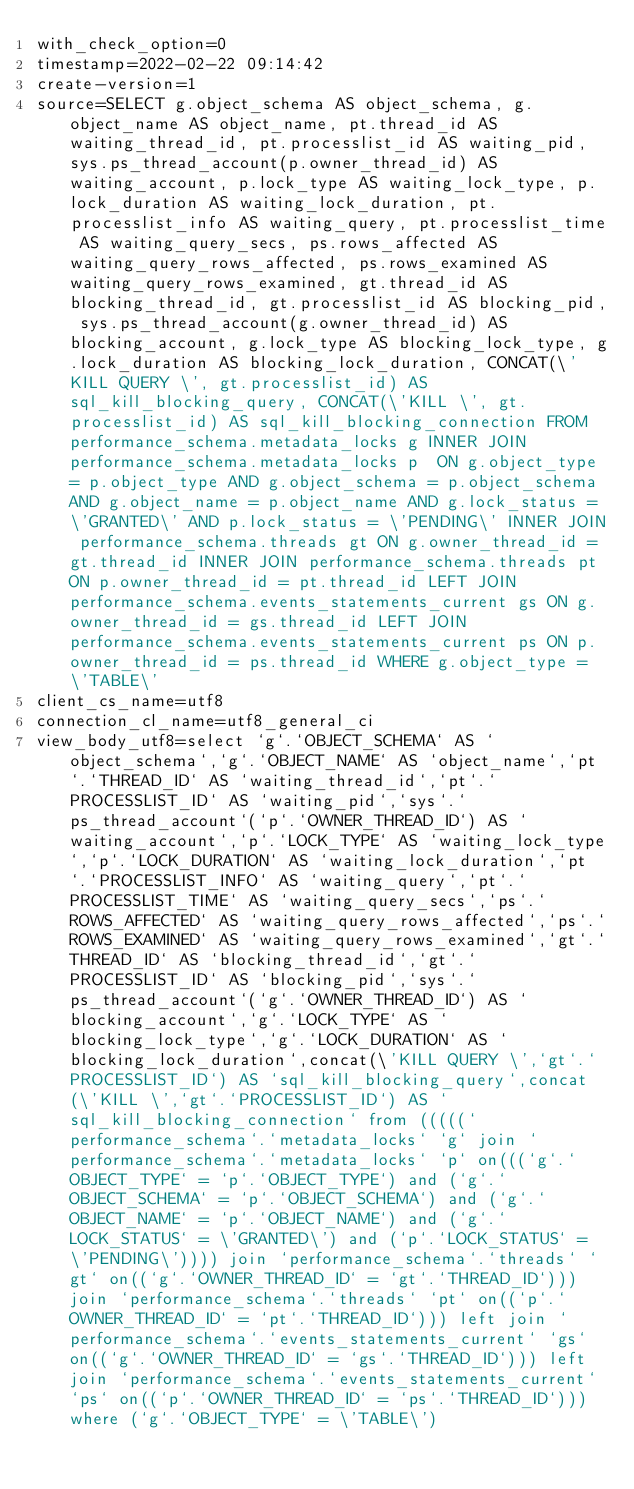Convert code to text. <code><loc_0><loc_0><loc_500><loc_500><_VisualBasic_>with_check_option=0
timestamp=2022-02-22 09:14:42
create-version=1
source=SELECT g.object_schema AS object_schema, g.object_name AS object_name, pt.thread_id AS waiting_thread_id, pt.processlist_id AS waiting_pid, sys.ps_thread_account(p.owner_thread_id) AS waiting_account, p.lock_type AS waiting_lock_type, p.lock_duration AS waiting_lock_duration, pt.processlist_info AS waiting_query, pt.processlist_time AS waiting_query_secs, ps.rows_affected AS waiting_query_rows_affected, ps.rows_examined AS waiting_query_rows_examined, gt.thread_id AS blocking_thread_id, gt.processlist_id AS blocking_pid, sys.ps_thread_account(g.owner_thread_id) AS blocking_account, g.lock_type AS blocking_lock_type, g.lock_duration AS blocking_lock_duration, CONCAT(\'KILL QUERY \', gt.processlist_id) AS sql_kill_blocking_query, CONCAT(\'KILL \', gt.processlist_id) AS sql_kill_blocking_connection FROM performance_schema.metadata_locks g INNER JOIN performance_schema.metadata_locks p  ON g.object_type = p.object_type AND g.object_schema = p.object_schema AND g.object_name = p.object_name AND g.lock_status = \'GRANTED\' AND p.lock_status = \'PENDING\' INNER JOIN performance_schema.threads gt ON g.owner_thread_id = gt.thread_id INNER JOIN performance_schema.threads pt ON p.owner_thread_id = pt.thread_id LEFT JOIN performance_schema.events_statements_current gs ON g.owner_thread_id = gs.thread_id LEFT JOIN performance_schema.events_statements_current ps ON p.owner_thread_id = ps.thread_id WHERE g.object_type = \'TABLE\'
client_cs_name=utf8
connection_cl_name=utf8_general_ci
view_body_utf8=select `g`.`OBJECT_SCHEMA` AS `object_schema`,`g`.`OBJECT_NAME` AS `object_name`,`pt`.`THREAD_ID` AS `waiting_thread_id`,`pt`.`PROCESSLIST_ID` AS `waiting_pid`,`sys`.`ps_thread_account`(`p`.`OWNER_THREAD_ID`) AS `waiting_account`,`p`.`LOCK_TYPE` AS `waiting_lock_type`,`p`.`LOCK_DURATION` AS `waiting_lock_duration`,`pt`.`PROCESSLIST_INFO` AS `waiting_query`,`pt`.`PROCESSLIST_TIME` AS `waiting_query_secs`,`ps`.`ROWS_AFFECTED` AS `waiting_query_rows_affected`,`ps`.`ROWS_EXAMINED` AS `waiting_query_rows_examined`,`gt`.`THREAD_ID` AS `blocking_thread_id`,`gt`.`PROCESSLIST_ID` AS `blocking_pid`,`sys`.`ps_thread_account`(`g`.`OWNER_THREAD_ID`) AS `blocking_account`,`g`.`LOCK_TYPE` AS `blocking_lock_type`,`g`.`LOCK_DURATION` AS `blocking_lock_duration`,concat(\'KILL QUERY \',`gt`.`PROCESSLIST_ID`) AS `sql_kill_blocking_query`,concat(\'KILL \',`gt`.`PROCESSLIST_ID`) AS `sql_kill_blocking_connection` from (((((`performance_schema`.`metadata_locks` `g` join `performance_schema`.`metadata_locks` `p` on(((`g`.`OBJECT_TYPE` = `p`.`OBJECT_TYPE`) and (`g`.`OBJECT_SCHEMA` = `p`.`OBJECT_SCHEMA`) and (`g`.`OBJECT_NAME` = `p`.`OBJECT_NAME`) and (`g`.`LOCK_STATUS` = \'GRANTED\') and (`p`.`LOCK_STATUS` = \'PENDING\')))) join `performance_schema`.`threads` `gt` on((`g`.`OWNER_THREAD_ID` = `gt`.`THREAD_ID`))) join `performance_schema`.`threads` `pt` on((`p`.`OWNER_THREAD_ID` = `pt`.`THREAD_ID`))) left join `performance_schema`.`events_statements_current` `gs` on((`g`.`OWNER_THREAD_ID` = `gs`.`THREAD_ID`))) left join `performance_schema`.`events_statements_current` `ps` on((`p`.`OWNER_THREAD_ID` = `ps`.`THREAD_ID`))) where (`g`.`OBJECT_TYPE` = \'TABLE\')
</code> 